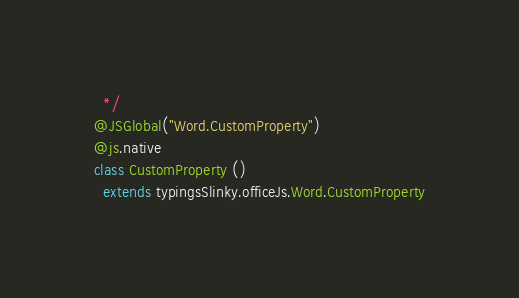<code> <loc_0><loc_0><loc_500><loc_500><_Scala_>  */
@JSGlobal("Word.CustomProperty")
@js.native
class CustomProperty ()
  extends typingsSlinky.officeJs.Word.CustomProperty
</code> 